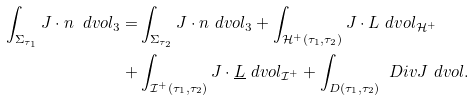Convert formula to latex. <formula><loc_0><loc_0><loc_500><loc_500>\int _ { \Sigma _ { \tau _ { 1 } } } J \cdot n \ d v o l _ { 3 } = & \int _ { \Sigma _ { \tau _ { 2 } } } J \cdot n \ d v o l _ { 3 } + \int _ { \mathcal { H } ^ { + } ( \tau _ { 1 } , \tau _ { 2 } ) } J \cdot L \ d v o l _ { \mathcal { H } ^ { + } } \\ + & \int _ { \mathcal { I } ^ { + } ( \tau _ { 1 } , \tau _ { 2 } ) } J \cdot \underline { L } \ d v o l _ { \mathcal { I } ^ { + } } + \int _ { D ( \tau _ { 1 } , \tau _ { 2 } ) } \ D i v J \ d v o l .</formula> 